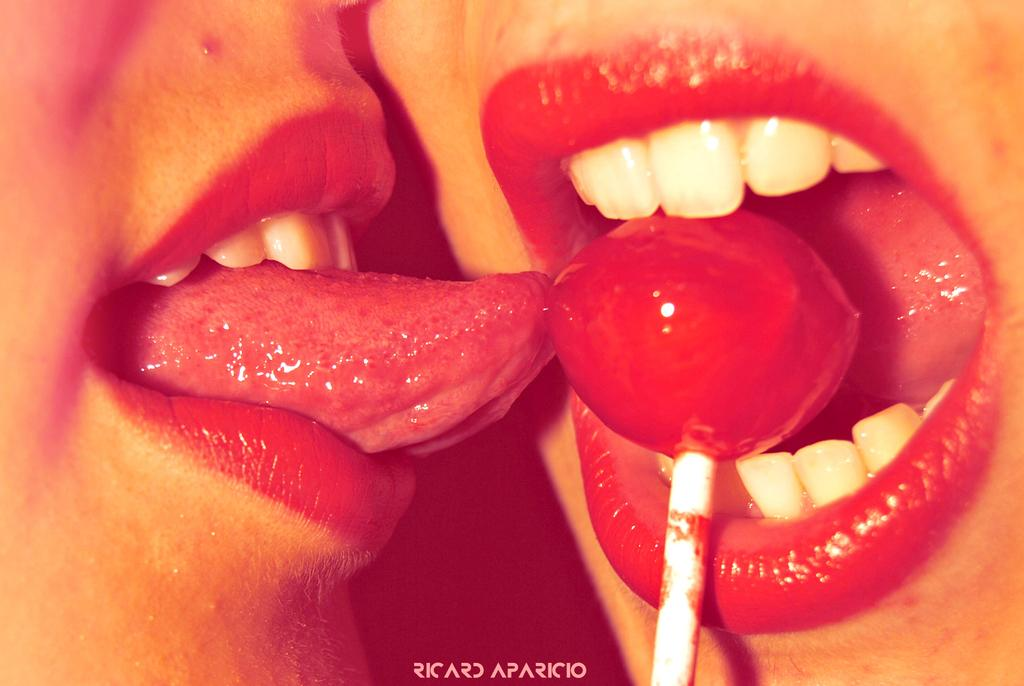What can be seen in the image related to the mouth? There are two persons' mouths in the image. What object is present in the image that is typically associated with sweet treats? There is a lollipop in the image. What information can be found at the bottom of the image? There is text at the bottom of the image. How many flowers are visible in the image? There are no flowers present in the image. Can you describe the rat's behavior in the image? There is no rat present in the image. 